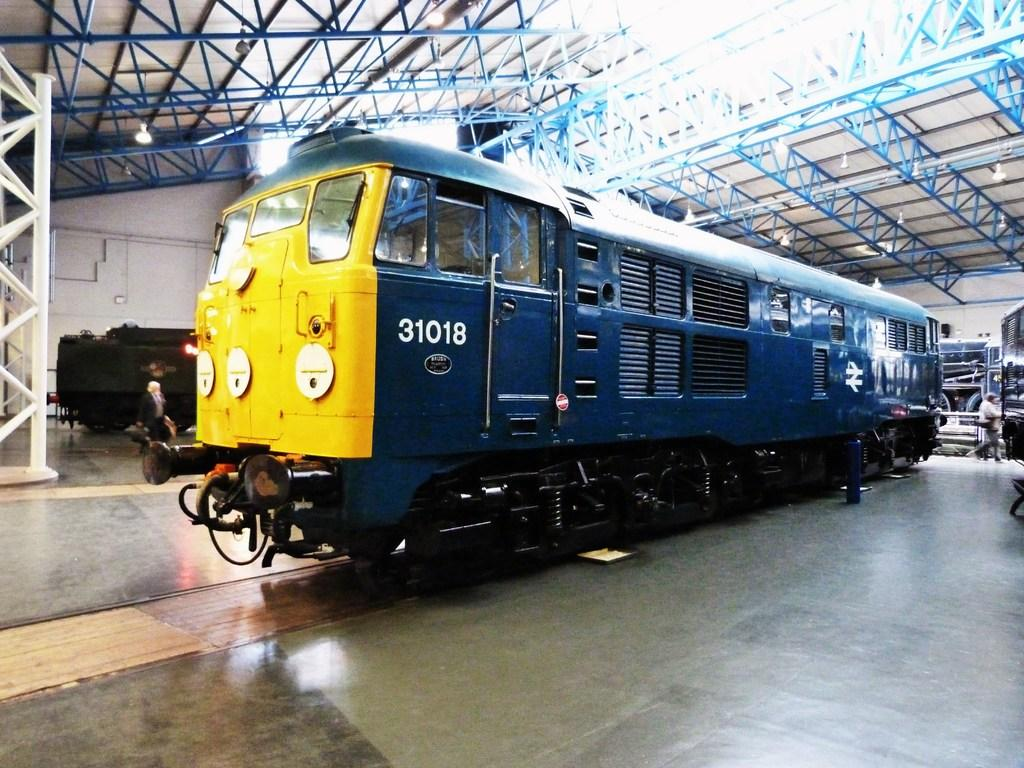<image>
Provide a brief description of the given image. Blue and yellow Train engine 31018 sits inside a building 